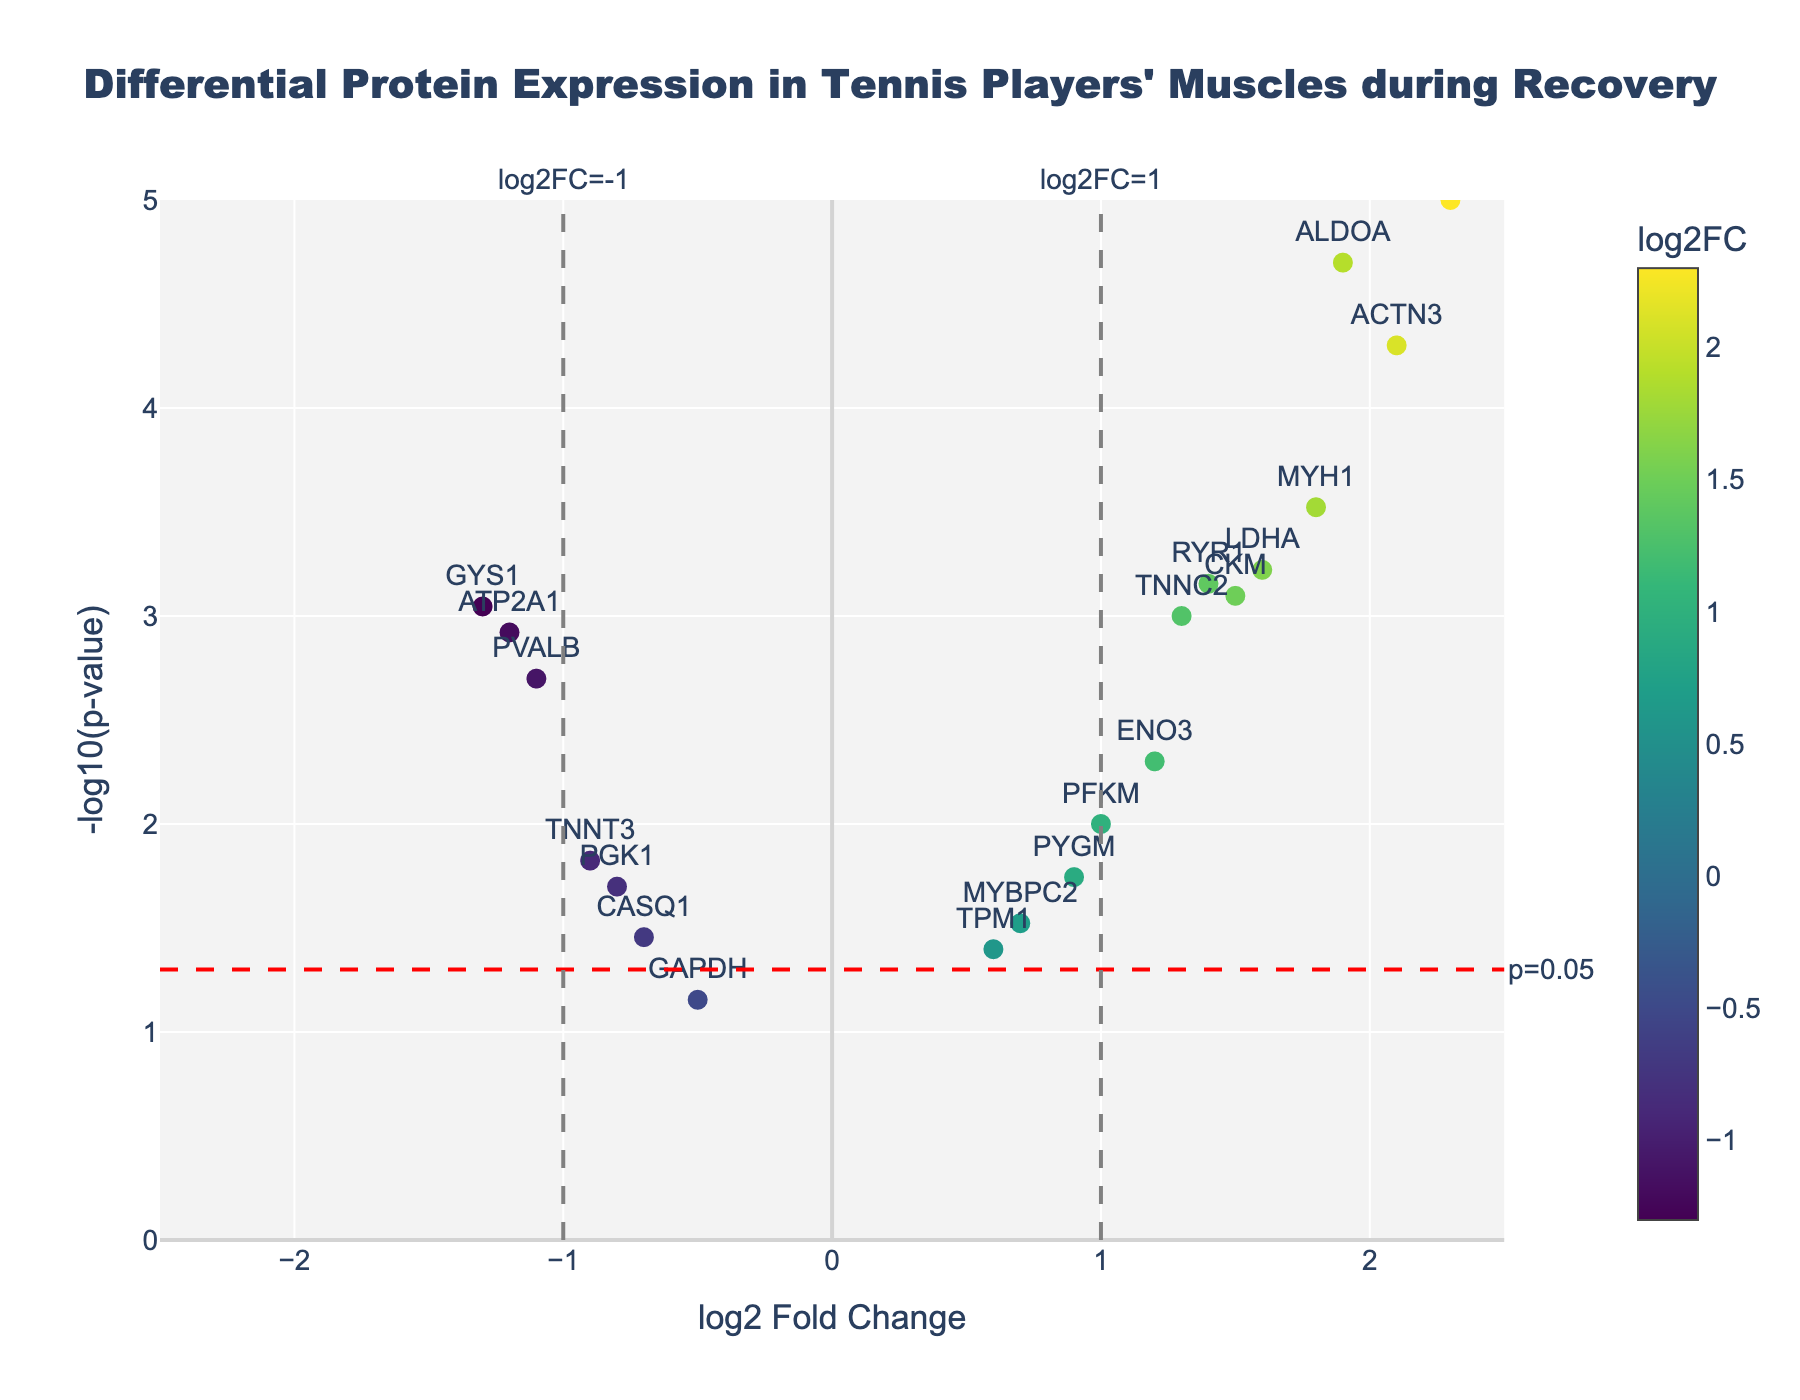What's the title of the plot? The title is located at the top of the figure, it summarizes the main focus of the plot.
Answer: Differential Protein Expression in Tennis Players' Muscles during Recovery What do the x-axis and y-axis represent? The labels at the bottom and left side of the plot indicate what each axis measures. The x-axis represents the log2 Fold Change and the y-axis represents the -log10(p-value).
Answer: log2 Fold Change and -log10(p-value) How many genes have a log2 Fold Change greater than 1? Look at the points to the right of the vertical line at x=1. Count the points above this threshold.
Answer: 7 Which gene has the highest -log10(p-value)? Identify the point that is the highest on the y-axis. Look at the text labels to determine the gene name.
Answer: SLC2A4 Are there any genes with a log2 Fold Change less than -1 and a -log10(p-value) greater than 2? Check the region to the left of the vertical line at x=-1 and above the y=2 line. Count any points in this region and read their labels.
Answer: ATP2A1 and GYS1 Which gene has the largest positive log2 Fold Change? Identify the point farthest to the right on the x-axis and read the label for that gene.
Answer: SLC2A4 What color range is used for the points and what does it indicate? The color gradient, indicated by the color bar, generally transitions due to the log2 Fold Change values, from lower to higher. The colors range from darker to lighter tones.
Answer: Viridis colorscale ranging from dark to light Are there genes that do not meet the p-value threshold of 0.05? Look for points below the horizontal line marked with p=0.05 and check their labels. Count these points.
Answer: TPM1, MYBPC2, PYGM, CASQ1, GAPDH How many genes have statistically significant changes in expression (p < 0.05)? Count all data points above the red dashed horizontal line, which represents the p-value threshold.
Answer: 15 Which gene among CKM and MYH1 is closer to the origin in terms of log2 Fold Change and -log10(p-value)? Compare the coordinates (log2 Fold Change and -log10(p-value)) of CKM and MYH1 and see which is closer to the (0, 0) point by calculating the Euclidean distance.
Answer: CKM 